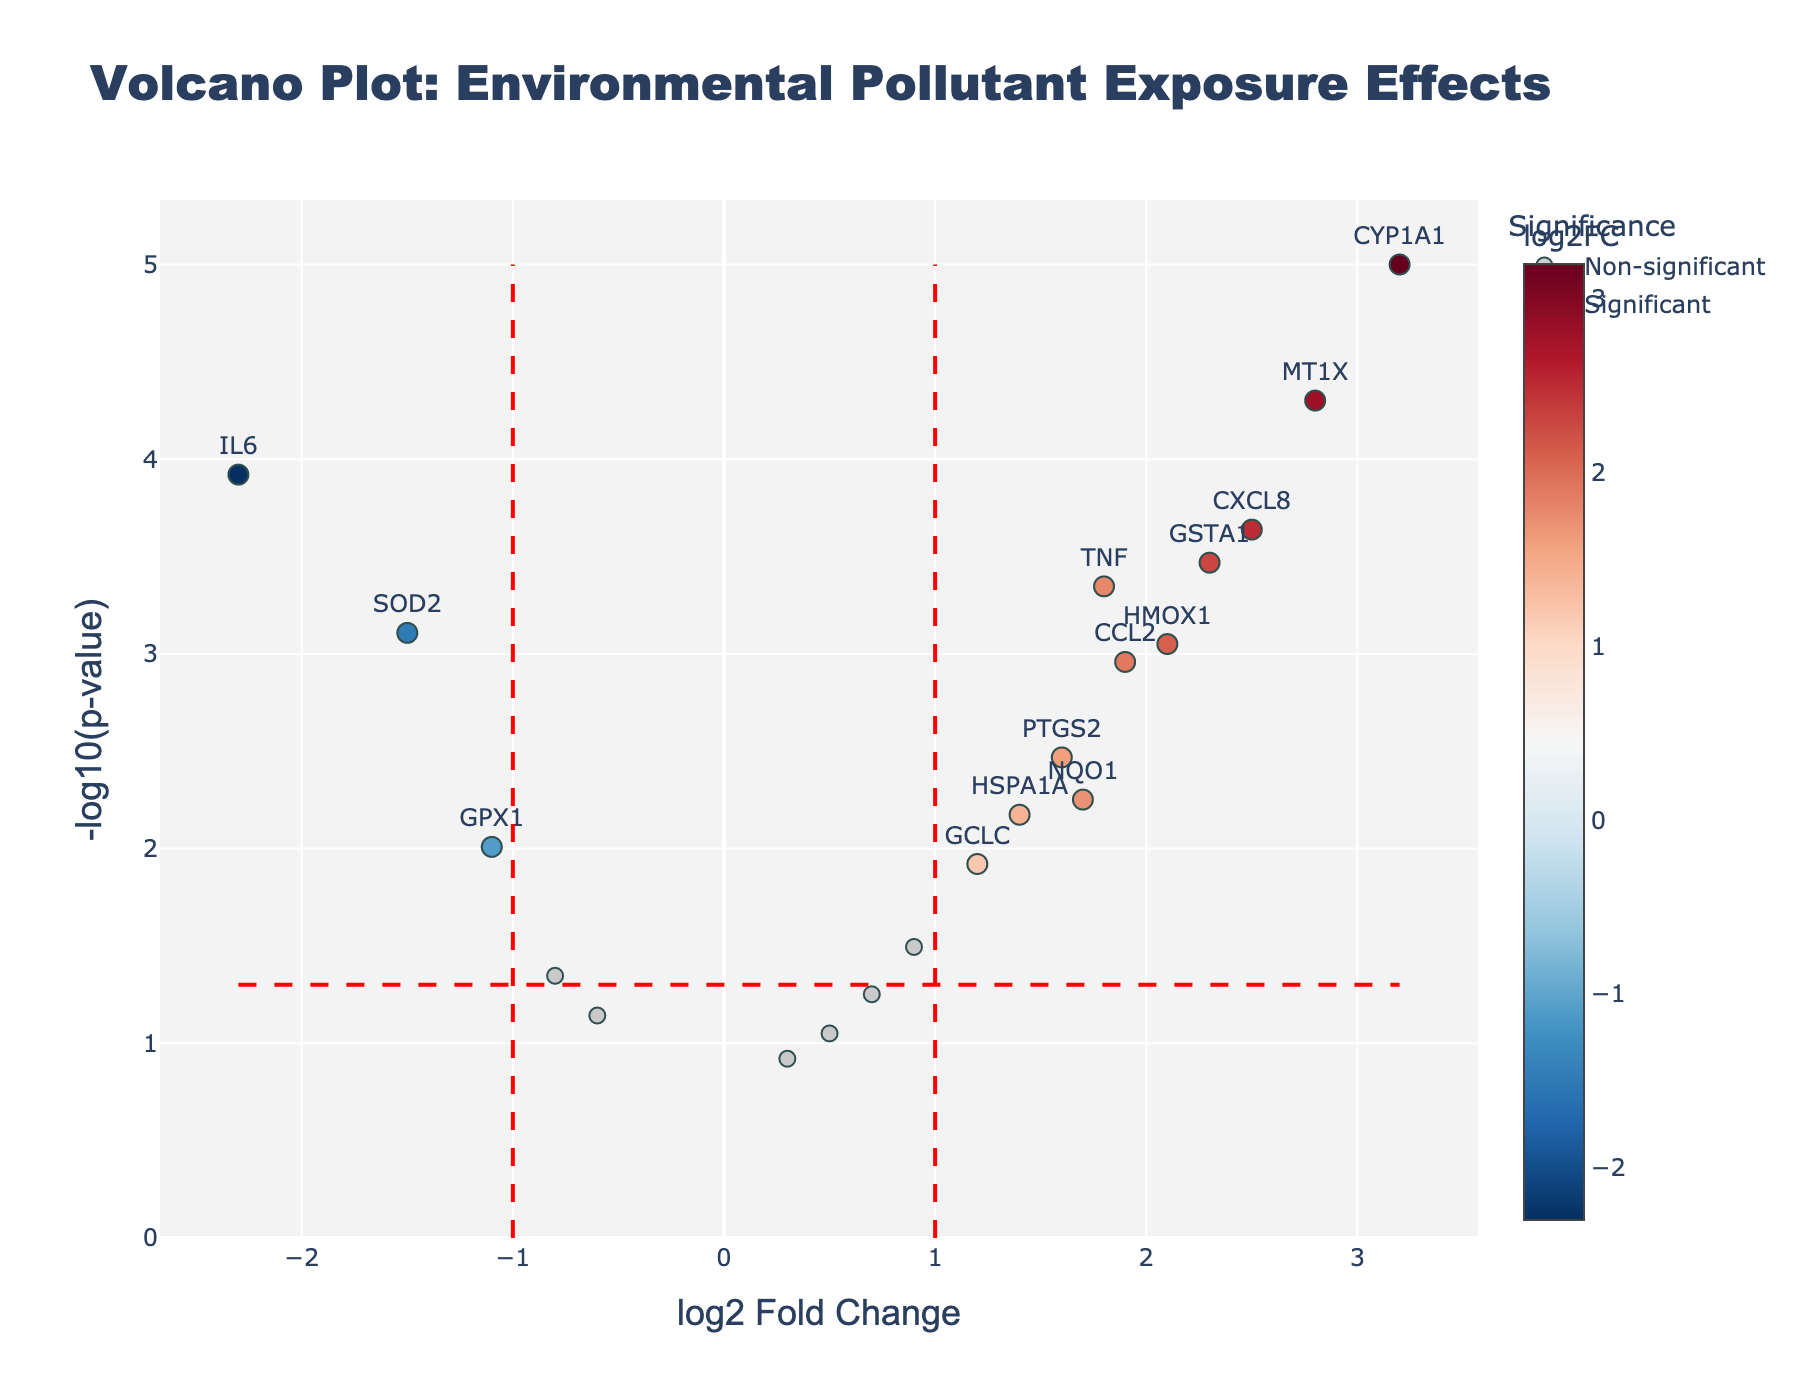How many genes are displayed in the figure? To find the number of genes displayed, count all the gene markers on the plot. There are 19 data points corresponding to each of the 19 genes in the dataset.
Answer: 19 What does a higher -log10(p-value) indicate? Higher -log10(p-value) values signify lower p-values, meaning greater statistical significance. This is because the -log10 transformation of a small p-value results in a larger value.
Answer: Greater statistical significance Which gene has the highest log2 fold change? To identify the gene with the highest log2 fold change, examine the rightmost data point on the x-axis. The gene CYP1A1 has the highest log2 fold change of 3.2.
Answer: CYP1A1 Which genes are significantly downregulated? Significant downregulation is indicated by a log2 fold change less than -1 and a p-value smaller than 0.05. The two genes meeting this criterion are IL6 and SOD2.
Answer: IL6, SOD2 How many genes have a log2 fold change above 2 and are considered statistically significant? Count the genes that meet both criteria: log2 fold change > 2 and p-value < 0.05. The genes MT1X and CYP1A1 fit these parameters.
Answer: 2 What threshold is used on the x-axis to demarcate significance? The plot uses vertical lines at log2 fold change values of -1 and 1 to separate significant from non-significant changes.
Answer: -1 and 1 Which gene has the lowest p-value? The gene with the highest -log10(p-value) in the y-axis represents the lowest p-value. CYP1A1 has the lowest p-value.
Answer: CYP1A1 What color represents significant genes with positive log2 fold change? Significant genes with positive log2 fold change are depicted in colors from a scale ranging from blue to red, where a higher log2 fold change results in a warmer color (closer to red).
Answer: Red to blue gradient, more red for higher values Compare the fold changes of GSTA1 and BAX. Which one is higher? Examine the log2 fold change values for both genes. GSTA1 has a log2 fold change of 2.3, whereas BAX has a log2 fold change of 0.5. GSTA1 has a higher fold change.
Answer: GSTA1 